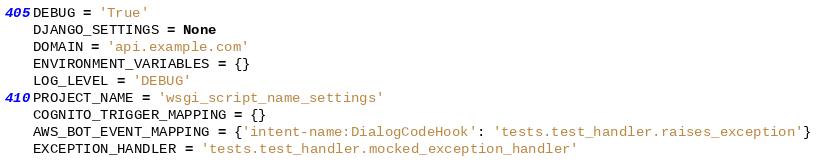<code> <loc_0><loc_0><loc_500><loc_500><_Python_>DEBUG = 'True'
DJANGO_SETTINGS = None
DOMAIN = 'api.example.com'
ENVIRONMENT_VARIABLES = {}
LOG_LEVEL = 'DEBUG'
PROJECT_NAME = 'wsgi_script_name_settings'
COGNITO_TRIGGER_MAPPING = {}
AWS_BOT_EVENT_MAPPING = {'intent-name:DialogCodeHook': 'tests.test_handler.raises_exception'}
EXCEPTION_HANDLER = 'tests.test_handler.mocked_exception_handler'
</code> 